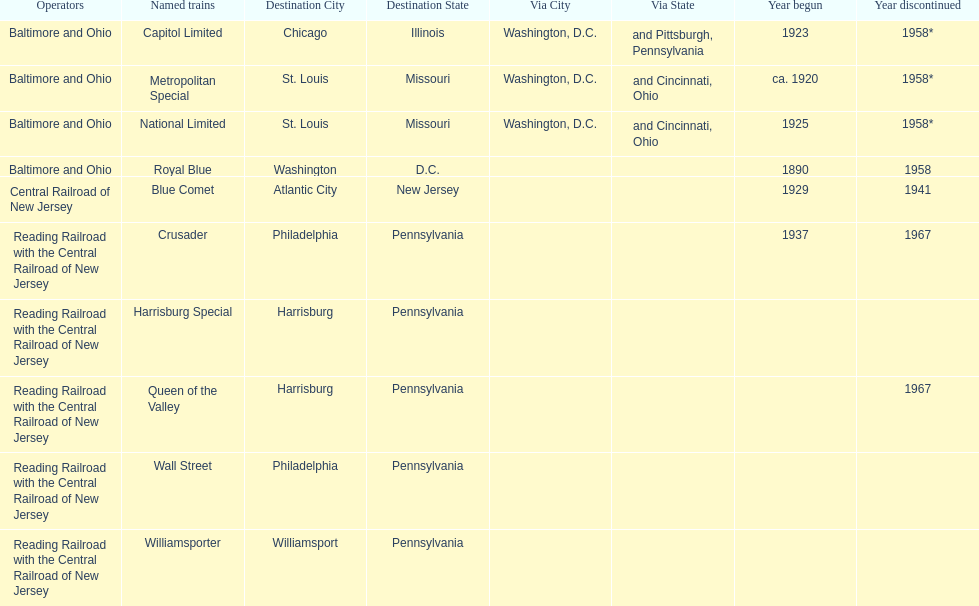Which train ran for the longest time? Royal Blue. 